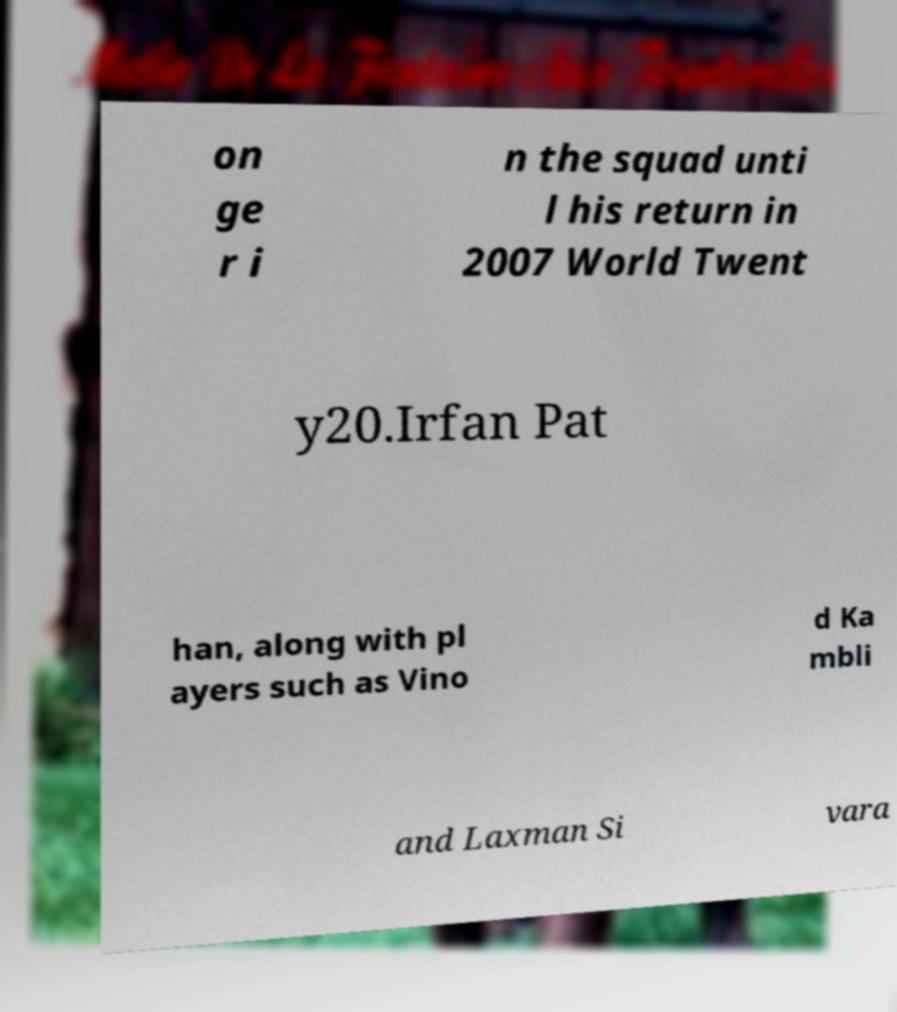Please read and relay the text visible in this image. What does it say? on ge r i n the squad unti l his return in 2007 World Twent y20.Irfan Pat han, along with pl ayers such as Vino d Ka mbli and Laxman Si vara 